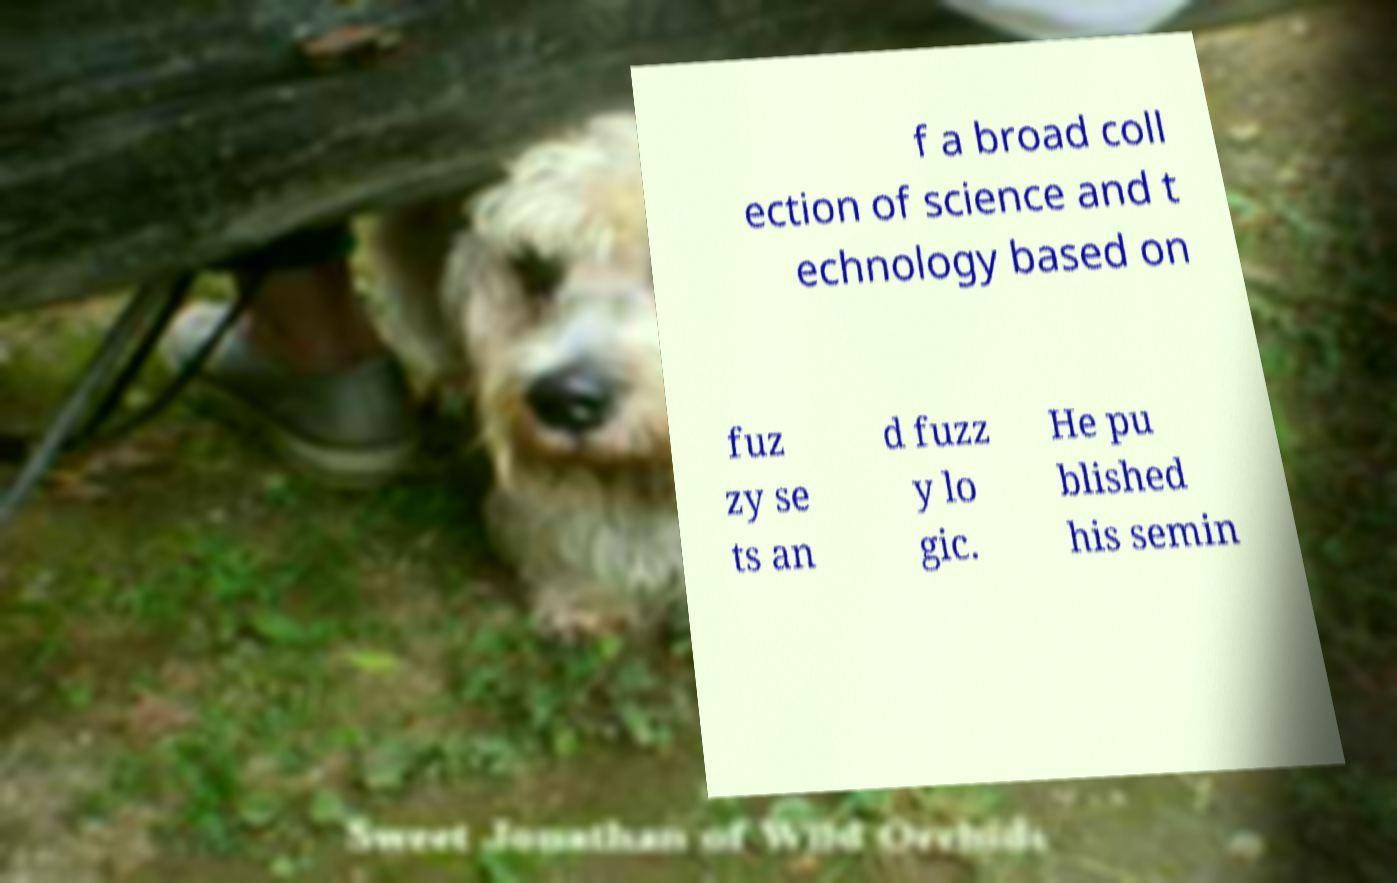What messages or text are displayed in this image? I need them in a readable, typed format. f a broad coll ection of science and t echnology based on fuz zy se ts an d fuzz y lo gic. He pu blished his semin 